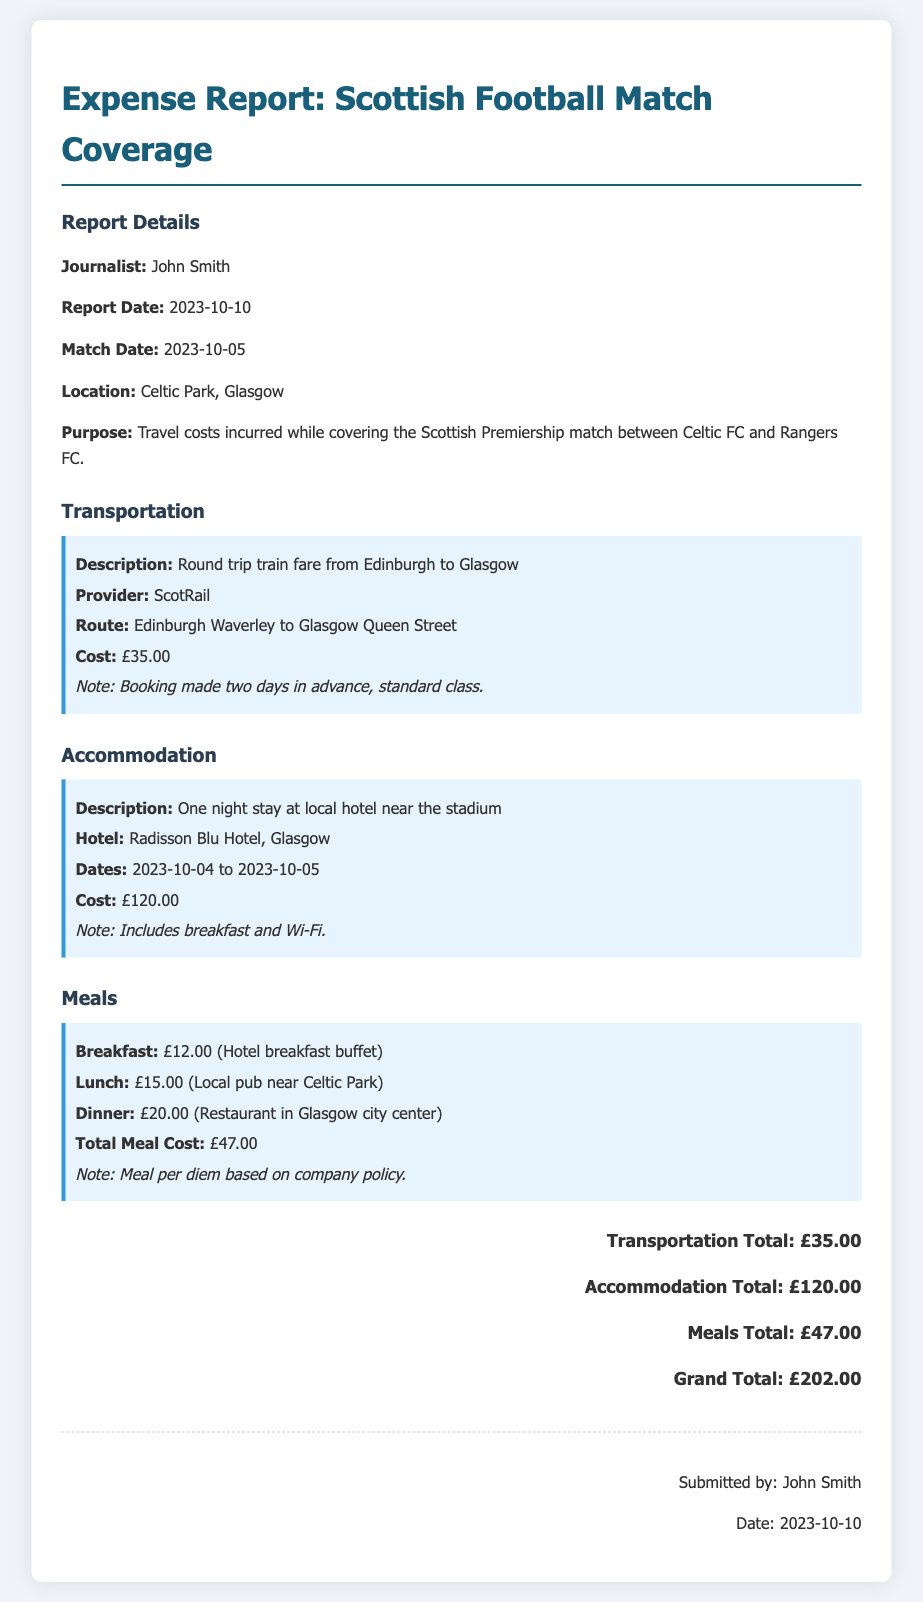What is the journalist's name? The journalist's name is specified in the report under "Journalist."
Answer: John Smith What was the match date? The match date is provided in the report under "Match Date."
Answer: 2023-10-05 What is the total meal cost? The total meal cost is calculated and displayed in the Meals section.
Answer: £47.00 How much did the accommodation cost? The accommodation cost is mentioned under the Accommodation section.
Answer: £120.00 What is the grand total of the expenses? The grand total is the sum of all expenses at the end of the report.
Answer: £202.00 What date was the expense report submitted? The submission date is mentioned in the signature section of the report.
Answer: 2023-10-10 What type of transportation was used? The transportation details are listed under the Transportation section.
Answer: Train How many nights was the accommodation booked for? The accommodation section specifies the duration of the stay.
Answer: One night What is the purpose of the trip? The purpose is provided in the report details section.
Answer: Covering the Scottish Premiership match 